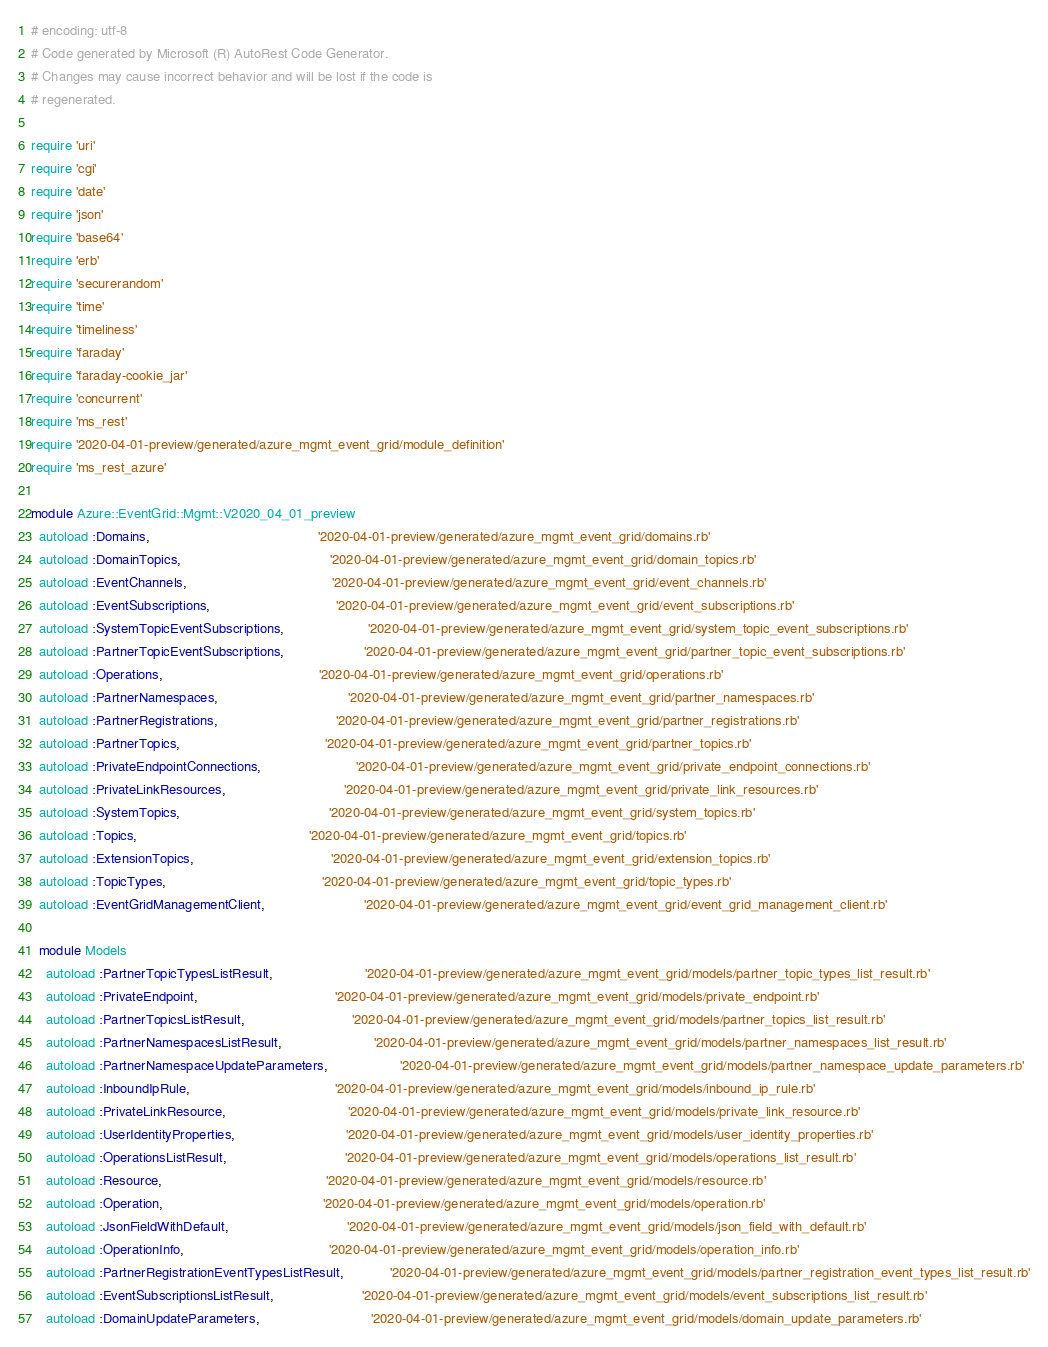<code> <loc_0><loc_0><loc_500><loc_500><_Ruby_># encoding: utf-8
# Code generated by Microsoft (R) AutoRest Code Generator.
# Changes may cause incorrect behavior and will be lost if the code is
# regenerated.

require 'uri'
require 'cgi'
require 'date'
require 'json'
require 'base64'
require 'erb'
require 'securerandom'
require 'time'
require 'timeliness'
require 'faraday'
require 'faraday-cookie_jar'
require 'concurrent'
require 'ms_rest'
require '2020-04-01-preview/generated/azure_mgmt_event_grid/module_definition'
require 'ms_rest_azure'

module Azure::EventGrid::Mgmt::V2020_04_01_preview
  autoload :Domains,                                            '2020-04-01-preview/generated/azure_mgmt_event_grid/domains.rb'
  autoload :DomainTopics,                                       '2020-04-01-preview/generated/azure_mgmt_event_grid/domain_topics.rb'
  autoload :EventChannels,                                      '2020-04-01-preview/generated/azure_mgmt_event_grid/event_channels.rb'
  autoload :EventSubscriptions,                                 '2020-04-01-preview/generated/azure_mgmt_event_grid/event_subscriptions.rb'
  autoload :SystemTopicEventSubscriptions,                      '2020-04-01-preview/generated/azure_mgmt_event_grid/system_topic_event_subscriptions.rb'
  autoload :PartnerTopicEventSubscriptions,                     '2020-04-01-preview/generated/azure_mgmt_event_grid/partner_topic_event_subscriptions.rb'
  autoload :Operations,                                         '2020-04-01-preview/generated/azure_mgmt_event_grid/operations.rb'
  autoload :PartnerNamespaces,                                  '2020-04-01-preview/generated/azure_mgmt_event_grid/partner_namespaces.rb'
  autoload :PartnerRegistrations,                               '2020-04-01-preview/generated/azure_mgmt_event_grid/partner_registrations.rb'
  autoload :PartnerTopics,                                      '2020-04-01-preview/generated/azure_mgmt_event_grid/partner_topics.rb'
  autoload :PrivateEndpointConnections,                         '2020-04-01-preview/generated/azure_mgmt_event_grid/private_endpoint_connections.rb'
  autoload :PrivateLinkResources,                               '2020-04-01-preview/generated/azure_mgmt_event_grid/private_link_resources.rb'
  autoload :SystemTopics,                                       '2020-04-01-preview/generated/azure_mgmt_event_grid/system_topics.rb'
  autoload :Topics,                                             '2020-04-01-preview/generated/azure_mgmt_event_grid/topics.rb'
  autoload :ExtensionTopics,                                    '2020-04-01-preview/generated/azure_mgmt_event_grid/extension_topics.rb'
  autoload :TopicTypes,                                         '2020-04-01-preview/generated/azure_mgmt_event_grid/topic_types.rb'
  autoload :EventGridManagementClient,                          '2020-04-01-preview/generated/azure_mgmt_event_grid/event_grid_management_client.rb'

  module Models
    autoload :PartnerTopicTypesListResult,                        '2020-04-01-preview/generated/azure_mgmt_event_grid/models/partner_topic_types_list_result.rb'
    autoload :PrivateEndpoint,                                    '2020-04-01-preview/generated/azure_mgmt_event_grid/models/private_endpoint.rb'
    autoload :PartnerTopicsListResult,                            '2020-04-01-preview/generated/azure_mgmt_event_grid/models/partner_topics_list_result.rb'
    autoload :PartnerNamespacesListResult,                        '2020-04-01-preview/generated/azure_mgmt_event_grid/models/partner_namespaces_list_result.rb'
    autoload :PartnerNamespaceUpdateParameters,                   '2020-04-01-preview/generated/azure_mgmt_event_grid/models/partner_namespace_update_parameters.rb'
    autoload :InboundIpRule,                                      '2020-04-01-preview/generated/azure_mgmt_event_grid/models/inbound_ip_rule.rb'
    autoload :PrivateLinkResource,                                '2020-04-01-preview/generated/azure_mgmt_event_grid/models/private_link_resource.rb'
    autoload :UserIdentityProperties,                             '2020-04-01-preview/generated/azure_mgmt_event_grid/models/user_identity_properties.rb'
    autoload :OperationsListResult,                               '2020-04-01-preview/generated/azure_mgmt_event_grid/models/operations_list_result.rb'
    autoload :Resource,                                           '2020-04-01-preview/generated/azure_mgmt_event_grid/models/resource.rb'
    autoload :Operation,                                          '2020-04-01-preview/generated/azure_mgmt_event_grid/models/operation.rb'
    autoload :JsonFieldWithDefault,                               '2020-04-01-preview/generated/azure_mgmt_event_grid/models/json_field_with_default.rb'
    autoload :OperationInfo,                                      '2020-04-01-preview/generated/azure_mgmt_event_grid/models/operation_info.rb'
    autoload :PartnerRegistrationEventTypesListResult,            '2020-04-01-preview/generated/azure_mgmt_event_grid/models/partner_registration_event_types_list_result.rb'
    autoload :EventSubscriptionsListResult,                       '2020-04-01-preview/generated/azure_mgmt_event_grid/models/event_subscriptions_list_result.rb'
    autoload :DomainUpdateParameters,                             '2020-04-01-preview/generated/azure_mgmt_event_grid/models/domain_update_parameters.rb'</code> 